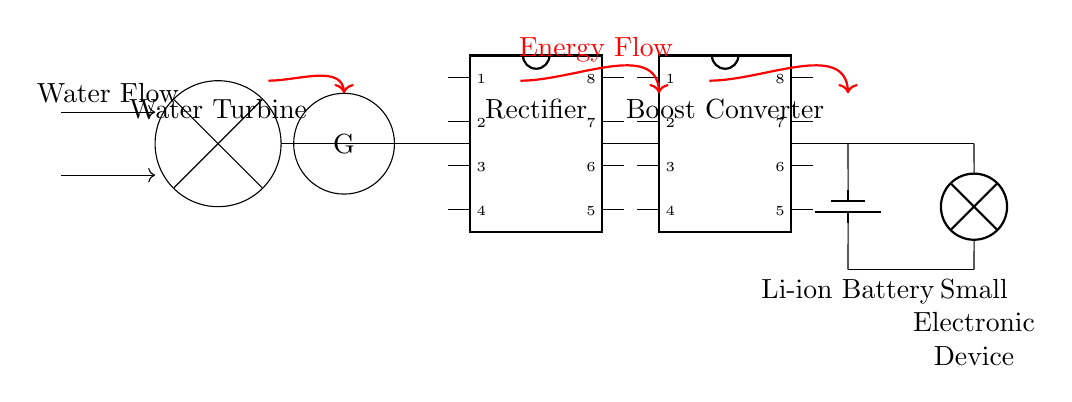What component converts mechanical energy to electrical energy? The water turbine is the component responsible for converting mechanical energy from water flow into electrical energy. It captures the kinetic energy of water and spins to generate electricity.
Answer: Water Turbine What does the rectifier do in this circuit? The rectifier converts the alternating current (AC) generated by the water turbine into direct current (DC), allowing it to be used to charge the battery and power the electronic device.
Answer: Converts AC to DC What is the purpose of the boost converter? The boost converter steps up the voltage from the rectifier to a higher level suitable for charging the Li-ion battery and powering the connected electronic device, which often requires a higher voltage than the rectified output.
Answer: Voltage increase How many components are used to store energy? The circuit includes one energy storage component, which is the Li-ion battery, designed to store the electrical energy generated before supplying it to the load.
Answer: One What is the main source of energy in this circuit? The main source of energy in this circuit is the water flow, which powers the water turbine to generate electricity for charging the battery and running the electronic device.
Answer: Water flow What type of current does the load receive? The load receives direct current (DC), as the output from the rectifier is converted from AC to DC before reaching the load, ensuring compatibility with typical electronic devices.
Answer: Direct current What is the role of the battery in this circuit? The role of the Li-ion battery is to store the electrical energy generated by the water turbine for later use, ensuring that the electronic device can be powered even when water flow is inconsistent.
Answer: Energy storage 